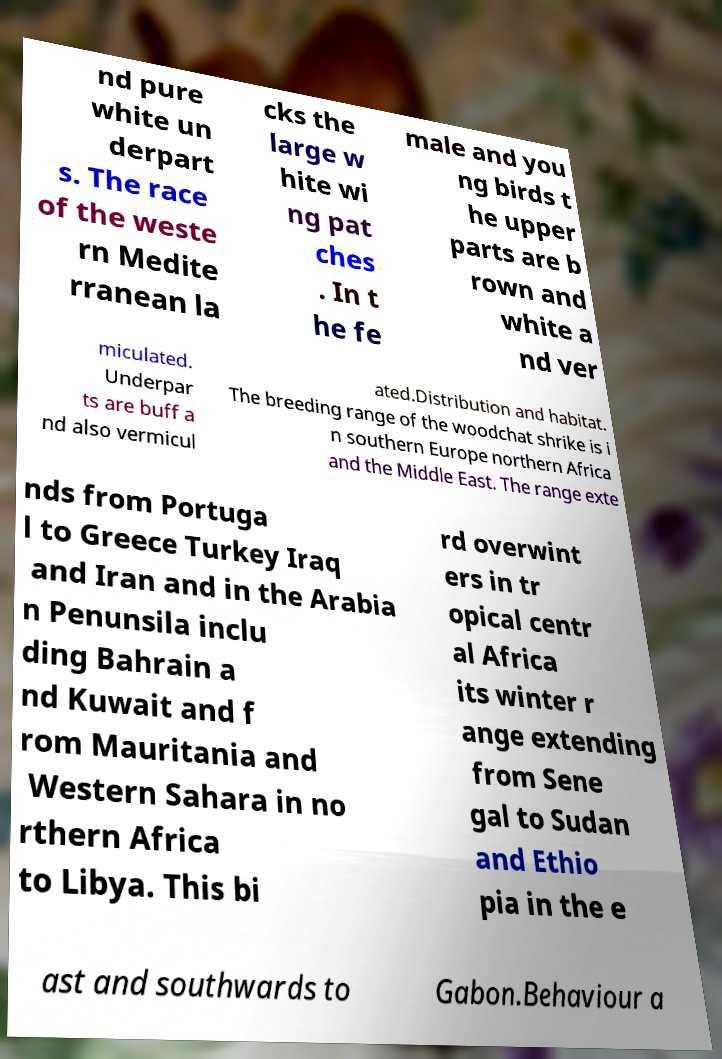Please read and relay the text visible in this image. What does it say? nd pure white un derpart s. The race of the weste rn Medite rranean la cks the large w hite wi ng pat ches . In t he fe male and you ng birds t he upper parts are b rown and white a nd ver miculated. Underpar ts are buff a nd also vermicul ated.Distribution and habitat. The breeding range of the woodchat shrike is i n southern Europe northern Africa and the Middle East. The range exte nds from Portuga l to Greece Turkey Iraq and Iran and in the Arabia n Penunsila inclu ding Bahrain a nd Kuwait and f rom Mauritania and Western Sahara in no rthern Africa to Libya. This bi rd overwint ers in tr opical centr al Africa its winter r ange extending from Sene gal to Sudan and Ethio pia in the e ast and southwards to Gabon.Behaviour a 